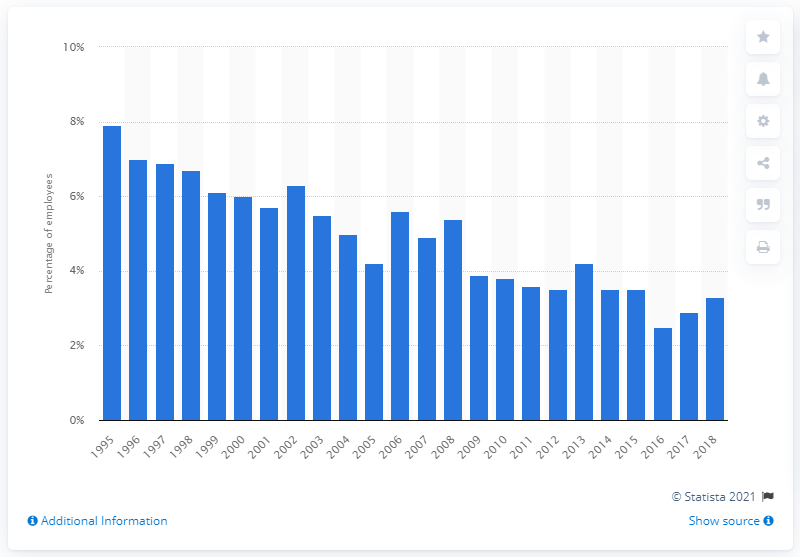Highlight a few significant elements in this photo. The trade union density in the hospitality and food service industry declined significantly between 1995 and 2018. 